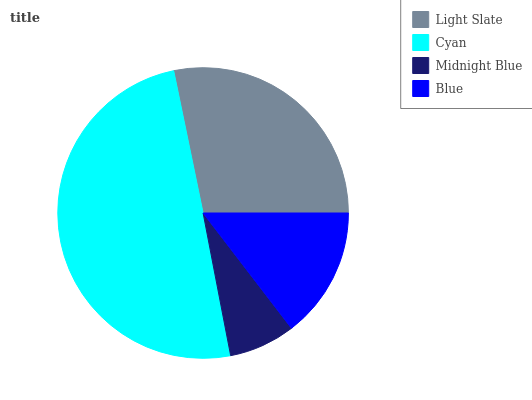Is Midnight Blue the minimum?
Answer yes or no. Yes. Is Cyan the maximum?
Answer yes or no. Yes. Is Cyan the minimum?
Answer yes or no. No. Is Midnight Blue the maximum?
Answer yes or no. No. Is Cyan greater than Midnight Blue?
Answer yes or no. Yes. Is Midnight Blue less than Cyan?
Answer yes or no. Yes. Is Midnight Blue greater than Cyan?
Answer yes or no. No. Is Cyan less than Midnight Blue?
Answer yes or no. No. Is Light Slate the high median?
Answer yes or no. Yes. Is Blue the low median?
Answer yes or no. Yes. Is Blue the high median?
Answer yes or no. No. Is Light Slate the low median?
Answer yes or no. No. 